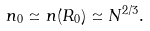Convert formula to latex. <formula><loc_0><loc_0><loc_500><loc_500>n _ { 0 } \simeq n ( R _ { 0 } ) \simeq N ^ { 2 / 3 } .</formula> 